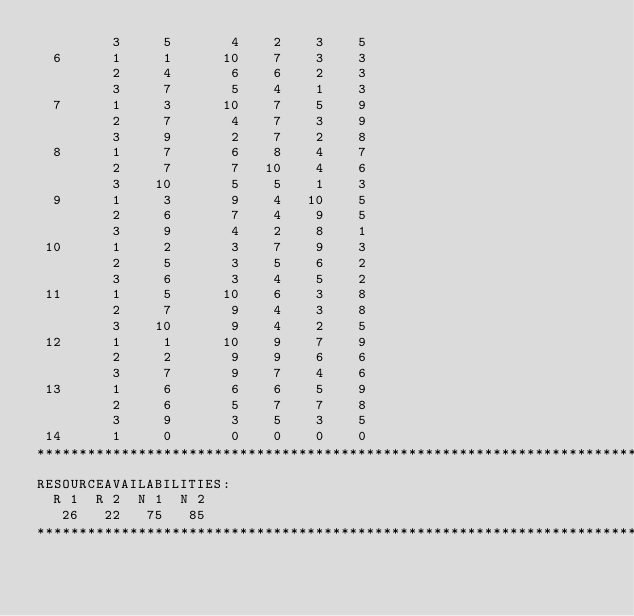Convert code to text. <code><loc_0><loc_0><loc_500><loc_500><_ObjectiveC_>         3     5       4    2    3    5
  6      1     1      10    7    3    3
         2     4       6    6    2    3
         3     7       5    4    1    3
  7      1     3      10    7    5    9
         2     7       4    7    3    9
         3     9       2    7    2    8
  8      1     7       6    8    4    7
         2     7       7   10    4    6
         3    10       5    5    1    3
  9      1     3       9    4   10    5
         2     6       7    4    9    5
         3     9       4    2    8    1
 10      1     2       3    7    9    3
         2     5       3    5    6    2
         3     6       3    4    5    2
 11      1     5      10    6    3    8
         2     7       9    4    3    8
         3    10       9    4    2    5
 12      1     1      10    9    7    9
         2     2       9    9    6    6
         3     7       9    7    4    6
 13      1     6       6    6    5    9
         2     6       5    7    7    8
         3     9       3    5    3    5
 14      1     0       0    0    0    0
************************************************************************
RESOURCEAVAILABILITIES:
  R 1  R 2  N 1  N 2
   26   22   75   85
************************************************************************
</code> 